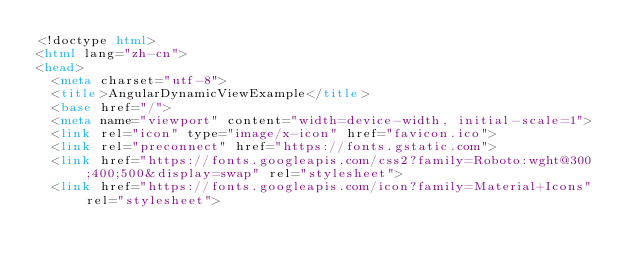Convert code to text. <code><loc_0><loc_0><loc_500><loc_500><_HTML_><!doctype html>
<html lang="zh-cn">
<head>
  <meta charset="utf-8">
  <title>AngularDynamicViewExample</title>
  <base href="/">
  <meta name="viewport" content="width=device-width, initial-scale=1">
  <link rel="icon" type="image/x-icon" href="favicon.ico">
  <link rel="preconnect" href="https://fonts.gstatic.com">
  <link href="https://fonts.googleapis.com/css2?family=Roboto:wght@300;400;500&display=swap" rel="stylesheet">
  <link href="https://fonts.googleapis.com/icon?family=Material+Icons" rel="stylesheet"></code> 